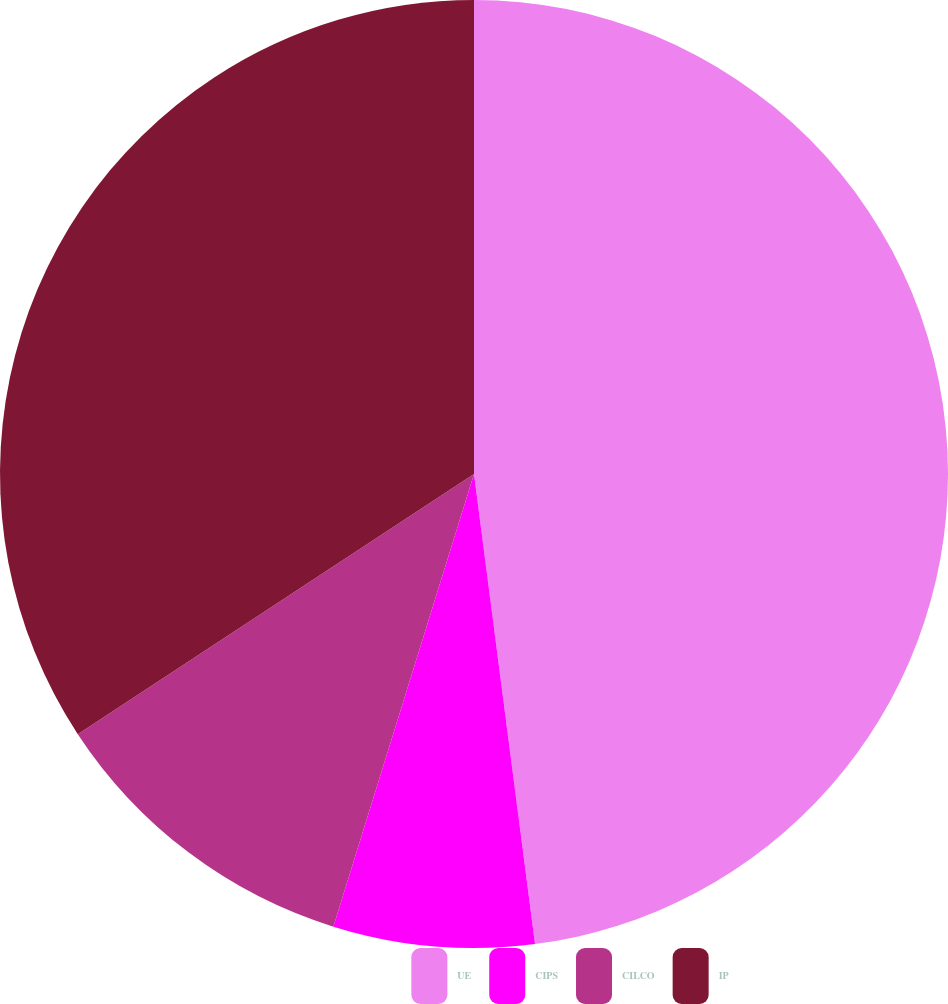Convert chart to OTSL. <chart><loc_0><loc_0><loc_500><loc_500><pie_chart><fcel>UE<fcel>CIPS<fcel>CILCO<fcel>IP<nl><fcel>47.95%<fcel>6.85%<fcel>10.96%<fcel>34.25%<nl></chart> 